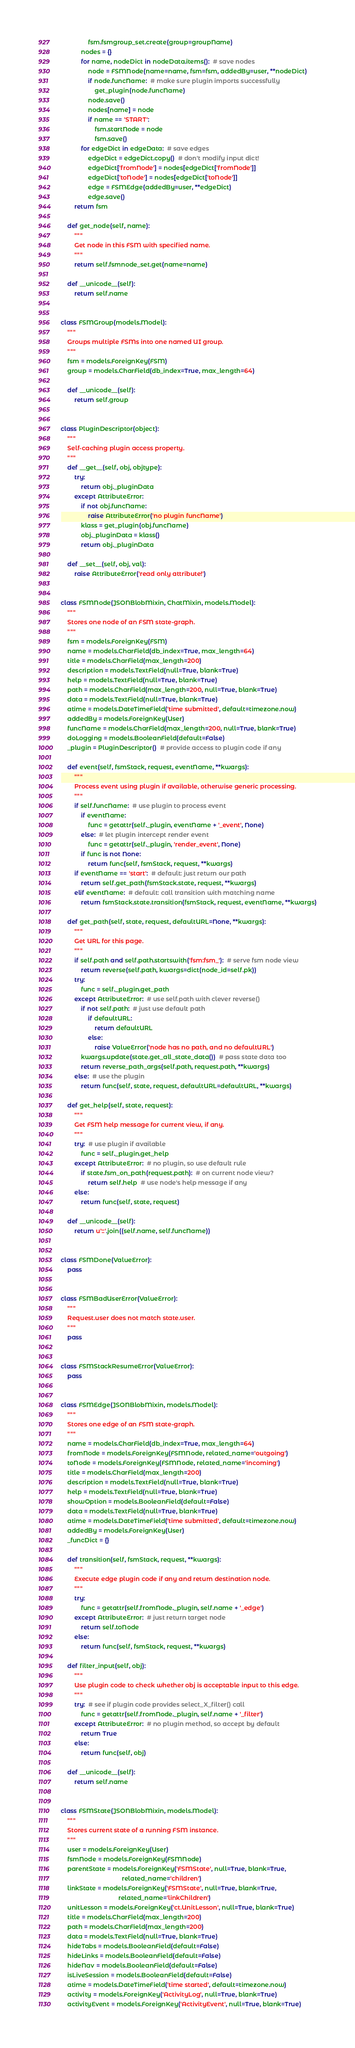Convert code to text. <code><loc_0><loc_0><loc_500><loc_500><_Python_>                fsm.fsmgroup_set.create(group=groupName)
            nodes = {}
            for name, nodeDict in nodeData.items():  # save nodes
                node = FSMNode(name=name, fsm=fsm, addedBy=user, **nodeDict)
                if node.funcName:  # make sure plugin imports successfully
                    get_plugin(node.funcName)
                node.save()
                nodes[name] = node
                if name == 'START':
                    fsm.startNode = node
                    fsm.save()
            for edgeDict in edgeData:  # save edges
                edgeDict = edgeDict.copy()  # don't modify input dict!
                edgeDict['fromNode'] = nodes[edgeDict['fromNode']]
                edgeDict['toNode'] = nodes[edgeDict['toNode']]
                edge = FSMEdge(addedBy=user, **edgeDict)
                edge.save()
        return fsm

    def get_node(self, name):
        """
        Get node in this FSM with specified name.
        """
        return self.fsmnode_set.get(name=name)

    def __unicode__(self):
        return self.name


class FSMGroup(models.Model):
    """
    Groups multiple FSMs into one named UI group.
    """
    fsm = models.ForeignKey(FSM)
    group = models.CharField(db_index=True, max_length=64)

    def __unicode__(self):
        return self.group


class PluginDescriptor(object):
    """
    Self-caching plugin access property.
    """
    def __get__(self, obj, objtype):
        try:
            return obj._pluginData
        except AttributeError:
            if not obj.funcName:
                raise AttributeError('no plugin funcName')
            klass = get_plugin(obj.funcName)
            obj._pluginData = klass()
            return obj._pluginData

    def __set__(self, obj, val):
        raise AttributeError('read only attribute!')


class FSMNode(JSONBlobMixin, ChatMixin, models.Model):
    """
    Stores one node of an FSM state-graph.
    """
    fsm = models.ForeignKey(FSM)
    name = models.CharField(db_index=True, max_length=64)
    title = models.CharField(max_length=200)
    description = models.TextField(null=True, blank=True)
    help = models.TextField(null=True, blank=True)
    path = models.CharField(max_length=200, null=True, blank=True)
    data = models.TextField(null=True, blank=True)
    atime = models.DateTimeField('time submitted', default=timezone.now)
    addedBy = models.ForeignKey(User)
    funcName = models.CharField(max_length=200, null=True, blank=True)
    doLogging = models.BooleanField(default=False)
    _plugin = PluginDescriptor()  # provide access to plugin code if any

    def event(self, fsmStack, request, eventName, **kwargs):
        """
        Process event using plugin if available, otherwise generic processing.
        """
        if self.funcName:  # use plugin to process event
            if eventName:
                func = getattr(self._plugin, eventName + '_event', None)
            else:  # let plugin intercept render event
                func = getattr(self._plugin, 'render_event', None)
            if func is not None:
                return func(self, fsmStack, request, **kwargs)
        if eventName == 'start':  # default: just return our path
            return self.get_path(fsmStack.state, request, **kwargs)
        elif eventName:  # default: call transition with matching name
            return fsmStack.state.transition(fsmStack, request, eventName, **kwargs)

    def get_path(self, state, request, defaultURL=None, **kwargs):
        """
        Get URL for this page.
        """
        if self.path and self.path.startswith('fsm:fsm_'):  # serve fsm node view
            return reverse(self.path, kwargs=dict(node_id=self.pk))
        try:
            func = self._plugin.get_path
        except AttributeError:  # use self.path with clever reverse()
            if not self.path:  # just use default path
                if defaultURL:
                    return defaultURL
                else:
                    raise ValueError('node has no path, and no defaultURL')
            kwargs.update(state.get_all_state_data())  # pass state data too
            return reverse_path_args(self.path, request.path, **kwargs)
        else:  # use the plugin
            return func(self, state, request, defaultURL=defaultURL, **kwargs)

    def get_help(self, state, request):
        """
        Get FSM help message for current view, if any.
        """
        try:  # use plugin if available
            func = self._plugin.get_help
        except AttributeError:  # no plugin, so use default rule
            if state.fsm_on_path(request.path):  # on current node view?
                return self.help  # use node's help message if any
        else:
            return func(self, state, request)

    def __unicode__(self):
        return u'::'.join((self.name, self.funcName))


class FSMDone(ValueError):
    pass


class FSMBadUserError(ValueError):
    """
    Request.user does not match state.user.
    """
    pass


class FSMStackResumeError(ValueError):
    pass


class FSMEdge(JSONBlobMixin, models.Model):
    """
    Stores one edge of an FSM state-graph.
    """
    name = models.CharField(db_index=True, max_length=64)
    fromNode = models.ForeignKey(FSMNode, related_name='outgoing')
    toNode = models.ForeignKey(FSMNode, related_name='incoming')
    title = models.CharField(max_length=200)
    description = models.TextField(null=True, blank=True)
    help = models.TextField(null=True, blank=True)
    showOption = models.BooleanField(default=False)
    data = models.TextField(null=True, blank=True)
    atime = models.DateTimeField('time submitted', default=timezone.now)
    addedBy = models.ForeignKey(User)
    _funcDict = {}

    def transition(self, fsmStack, request, **kwargs):
        """
        Execute edge plugin code if any and return destination node.
        """
        try:
            func = getattr(self.fromNode._plugin, self.name + '_edge')
        except AttributeError:  # just return target node
            return self.toNode
        else:
            return func(self, fsmStack, request, **kwargs)

    def filter_input(self, obj):
        """
        Use plugin code to check whether obj is acceptable input to this edge.
        """
        try:  # see if plugin code provides select_X_filter() call
            func = getattr(self.fromNode._plugin, self.name + '_filter')
        except AttributeError:  # no plugin method, so accept by default
            return True
        else:
            return func(self, obj)

    def __unicode__(self):
        return self.name


class FSMState(JSONBlobMixin, models.Model):
    """
    Stores current state of a running FSM instance.
    """
    user = models.ForeignKey(User)
    fsmNode = models.ForeignKey(FSMNode)
    parentState = models.ForeignKey('FSMState', null=True, blank=True,
                                    related_name='children')
    linkState = models.ForeignKey('FSMState', null=True, blank=True,
                                  related_name='linkChildren')
    unitLesson = models.ForeignKey('ct.UnitLesson', null=True, blank=True)
    title = models.CharField(max_length=200)
    path = models.CharField(max_length=200)
    data = models.TextField(null=True, blank=True)
    hideTabs = models.BooleanField(default=False)
    hideLinks = models.BooleanField(default=False)
    hideNav = models.BooleanField(default=False)
    isLiveSession = models.BooleanField(default=False)
    atime = models.DateTimeField('time started', default=timezone.now)
    activity = models.ForeignKey('ActivityLog', null=True, blank=True)
    activityEvent = models.ForeignKey('ActivityEvent', null=True, blank=True)
</code> 